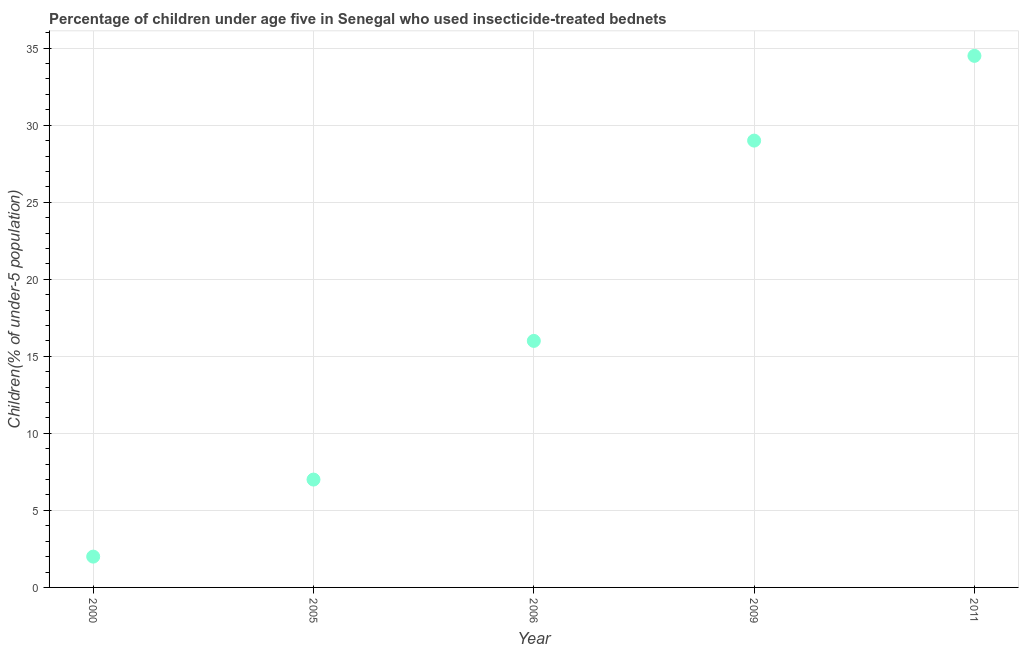Across all years, what is the maximum percentage of children who use of insecticide-treated bed nets?
Offer a very short reply. 34.5. Across all years, what is the minimum percentage of children who use of insecticide-treated bed nets?
Your answer should be compact. 2. What is the sum of the percentage of children who use of insecticide-treated bed nets?
Your response must be concise. 88.5. What is the difference between the percentage of children who use of insecticide-treated bed nets in 2005 and 2011?
Your answer should be compact. -27.5. What is the average percentage of children who use of insecticide-treated bed nets per year?
Provide a short and direct response. 17.7. What is the median percentage of children who use of insecticide-treated bed nets?
Keep it short and to the point. 16. In how many years, is the percentage of children who use of insecticide-treated bed nets greater than 12 %?
Give a very brief answer. 3. What is the ratio of the percentage of children who use of insecticide-treated bed nets in 2000 to that in 2009?
Provide a short and direct response. 0.07. Is the percentage of children who use of insecticide-treated bed nets in 2000 less than that in 2005?
Offer a terse response. Yes. What is the difference between the highest and the second highest percentage of children who use of insecticide-treated bed nets?
Keep it short and to the point. 5.5. What is the difference between the highest and the lowest percentage of children who use of insecticide-treated bed nets?
Offer a terse response. 32.5. In how many years, is the percentage of children who use of insecticide-treated bed nets greater than the average percentage of children who use of insecticide-treated bed nets taken over all years?
Your response must be concise. 2. How many dotlines are there?
Your response must be concise. 1. How many years are there in the graph?
Your answer should be compact. 5. What is the difference between two consecutive major ticks on the Y-axis?
Offer a terse response. 5. Are the values on the major ticks of Y-axis written in scientific E-notation?
Your answer should be very brief. No. Does the graph contain any zero values?
Keep it short and to the point. No. What is the title of the graph?
Offer a very short reply. Percentage of children under age five in Senegal who used insecticide-treated bednets. What is the label or title of the X-axis?
Offer a very short reply. Year. What is the label or title of the Y-axis?
Ensure brevity in your answer.  Children(% of under-5 population). What is the Children(% of under-5 population) in 2005?
Keep it short and to the point. 7. What is the Children(% of under-5 population) in 2011?
Keep it short and to the point. 34.5. What is the difference between the Children(% of under-5 population) in 2000 and 2009?
Provide a short and direct response. -27. What is the difference between the Children(% of under-5 population) in 2000 and 2011?
Your answer should be compact. -32.5. What is the difference between the Children(% of under-5 population) in 2005 and 2006?
Keep it short and to the point. -9. What is the difference between the Children(% of under-5 population) in 2005 and 2011?
Offer a very short reply. -27.5. What is the difference between the Children(% of under-5 population) in 2006 and 2009?
Give a very brief answer. -13. What is the difference between the Children(% of under-5 population) in 2006 and 2011?
Provide a succinct answer. -18.5. What is the ratio of the Children(% of under-5 population) in 2000 to that in 2005?
Keep it short and to the point. 0.29. What is the ratio of the Children(% of under-5 population) in 2000 to that in 2006?
Give a very brief answer. 0.12. What is the ratio of the Children(% of under-5 population) in 2000 to that in 2009?
Provide a succinct answer. 0.07. What is the ratio of the Children(% of under-5 population) in 2000 to that in 2011?
Provide a short and direct response. 0.06. What is the ratio of the Children(% of under-5 population) in 2005 to that in 2006?
Make the answer very short. 0.44. What is the ratio of the Children(% of under-5 population) in 2005 to that in 2009?
Provide a succinct answer. 0.24. What is the ratio of the Children(% of under-5 population) in 2005 to that in 2011?
Your answer should be compact. 0.2. What is the ratio of the Children(% of under-5 population) in 2006 to that in 2009?
Give a very brief answer. 0.55. What is the ratio of the Children(% of under-5 population) in 2006 to that in 2011?
Your answer should be very brief. 0.46. What is the ratio of the Children(% of under-5 population) in 2009 to that in 2011?
Provide a succinct answer. 0.84. 